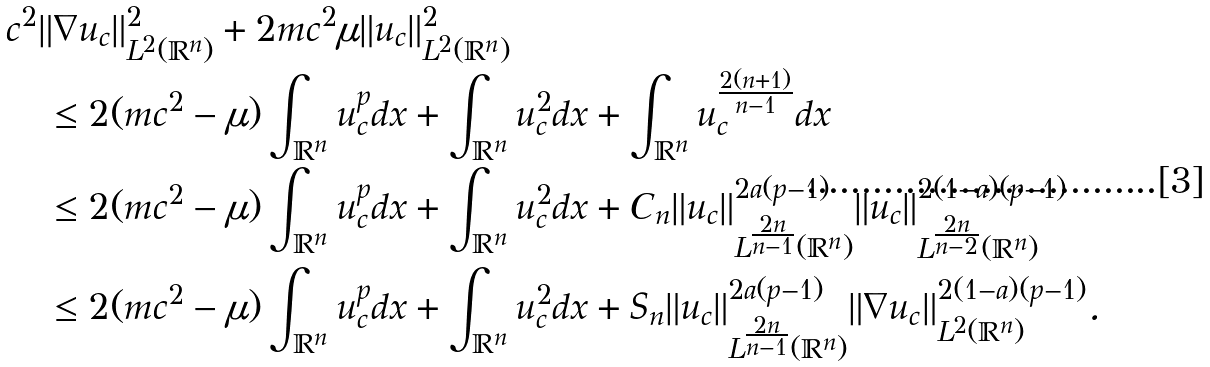<formula> <loc_0><loc_0><loc_500><loc_500>& c ^ { 2 } \| \nabla u _ { c } \| _ { L ^ { 2 } ( \mathbb { R } ^ { n } ) } ^ { 2 } + 2 m c ^ { 2 } \mu \| u _ { c } \| _ { L ^ { 2 } ( \mathbb { R } ^ { n } ) } ^ { 2 } \\ & \quad \leq 2 ( m c ^ { 2 } - \mu ) \int _ { \mathbb { R } ^ { n } } u _ { c } ^ { p } d x + \int _ { \mathbb { R } ^ { n } } u _ { c } ^ { 2 } d x + \int _ { \mathbb { R } ^ { n } } u _ { c } ^ { \frac { 2 ( n + 1 ) } { n - 1 } } d x \\ & \quad \leq 2 ( m c ^ { 2 } - \mu ) \int _ { \mathbb { R } ^ { n } } u _ { c } ^ { p } d x + \int _ { \mathbb { R } ^ { n } } u _ { c } ^ { 2 } d x + C _ { n } \| u _ { c } \| _ { L ^ { \frac { 2 n } { n - 1 } } ( \mathbb { R } ^ { n } ) } ^ { 2 a ( p - 1 ) } \| u _ { c } \| _ { L ^ { \frac { 2 n } { n - 2 } } ( \mathbb { R } ^ { n } ) } ^ { 2 ( 1 - a ) ( p - 1 ) } \\ & \quad \leq 2 ( m c ^ { 2 } - \mu ) \int _ { \mathbb { R } ^ { n } } u _ { c } ^ { p } d x + \int _ { \mathbb { R } ^ { n } } u _ { c } ^ { 2 } d x + S _ { n } \| u _ { c } \| _ { L ^ { \frac { 2 n } { n - 1 } } ( \mathbb { R } ^ { n } ) } ^ { 2 a ( p - 1 ) } \| \nabla u _ { c } \| _ { L ^ { 2 } ( \mathbb { R } ^ { n } ) } ^ { 2 ( 1 - a ) ( p - 1 ) } .</formula> 